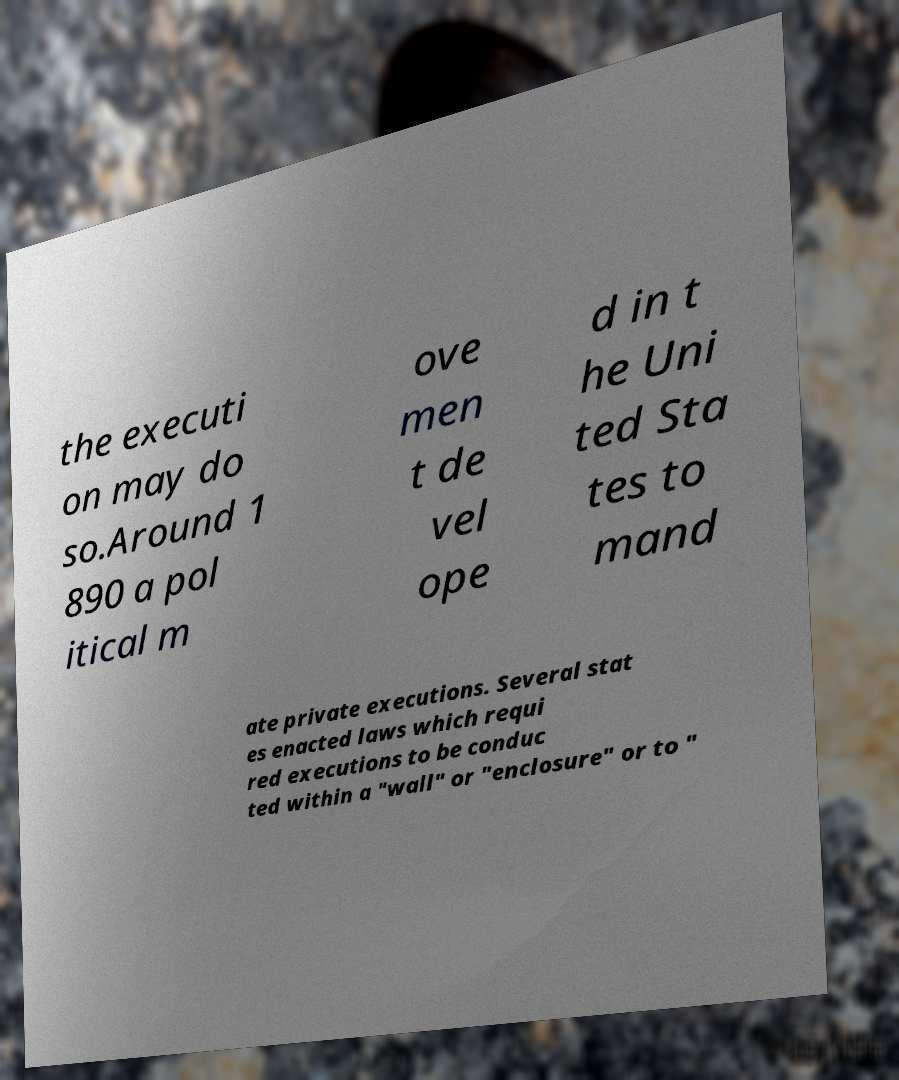I need the written content from this picture converted into text. Can you do that? the executi on may do so.Around 1 890 a pol itical m ove men t de vel ope d in t he Uni ted Sta tes to mand ate private executions. Several stat es enacted laws which requi red executions to be conduc ted within a "wall" or "enclosure" or to " 